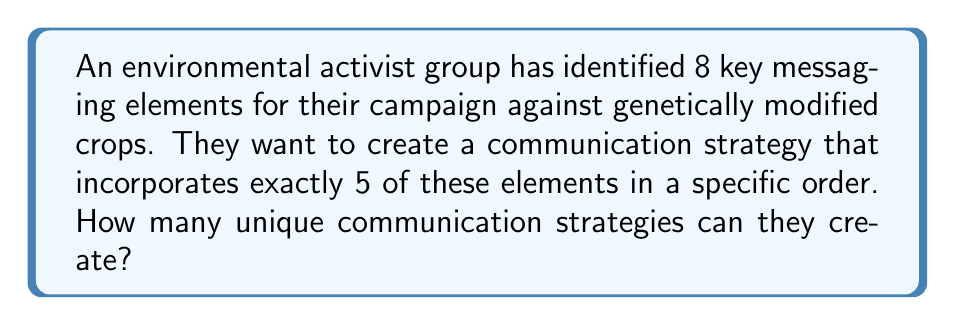Provide a solution to this math problem. To solve this problem, we need to use the concept of permutations. Here's a step-by-step explanation:

1. We have 8 messaging elements to choose from, and we need to select 5 of them.
2. The order of selection matters, as we're creating a specific sequence for the communication strategy.
3. We are not reusing any elements, so each element can only be used once.

This scenario fits the formula for permutations without repetition:

$$P(n,r) = \frac{n!}{(n-r)!}$$

Where:
$n$ = total number of elements to choose from
$r$ = number of elements being chosen

In our case:
$n = 8$ (total messaging elements)
$r = 5$ (elements used in each strategy)

Let's plug these values into the formula:

$$P(8,5) = \frac{8!}{(8-5)!} = \frac{8!}{3!}$$

Now, let's calculate:

$$\frac{8!}{3!} = \frac{8 \times 7 \times 6 \times 5 \times 4 \times 3!}{3!}$$

The $3!$ cancels out in the numerator and denominator:

$$= 8 \times 7 \times 6 \times 5 \times 4 = 6720$$

Therefore, the environmental activist group can create 6720 unique communication strategies.
Answer: 6720 